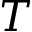Convert formula to latex. <formula><loc_0><loc_0><loc_500><loc_500>T</formula> 